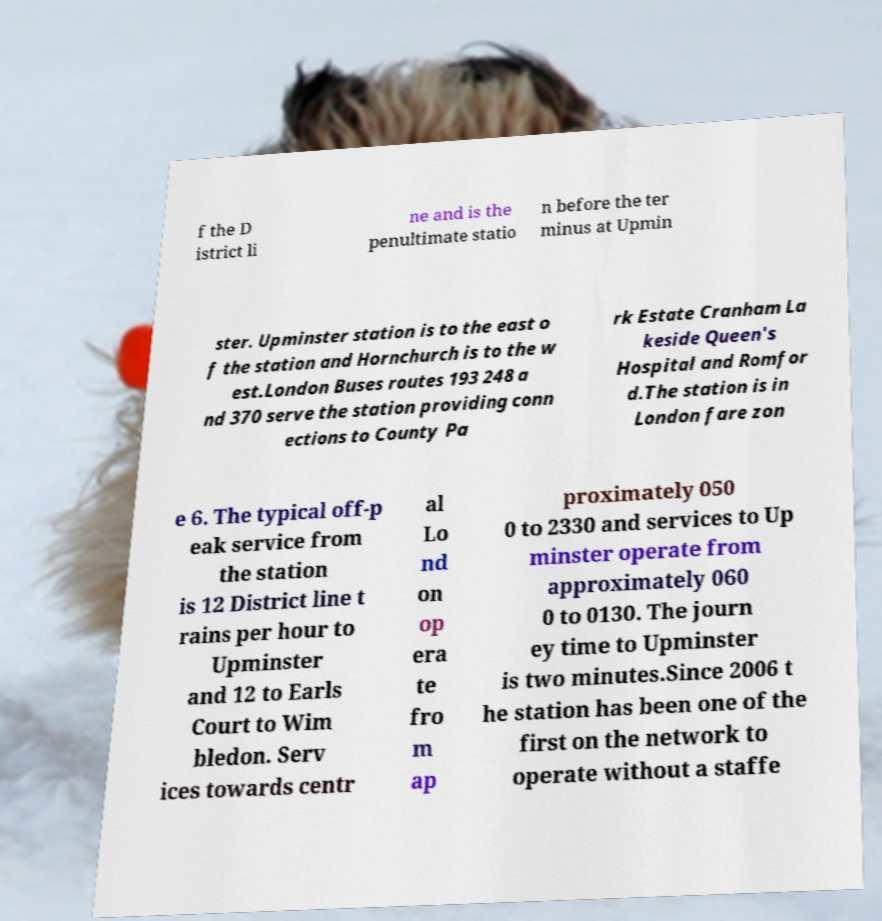What messages or text are displayed in this image? I need them in a readable, typed format. f the D istrict li ne and is the penultimate statio n before the ter minus at Upmin ster. Upminster station is to the east o f the station and Hornchurch is to the w est.London Buses routes 193 248 a nd 370 serve the station providing conn ections to County Pa rk Estate Cranham La keside Queen's Hospital and Romfor d.The station is in London fare zon e 6. The typical off-p eak service from the station is 12 District line t rains per hour to Upminster and 12 to Earls Court to Wim bledon. Serv ices towards centr al Lo nd on op era te fro m ap proximately 050 0 to 2330 and services to Up minster operate from approximately 060 0 to 0130. The journ ey time to Upminster is two minutes.Since 2006 t he station has been one of the first on the network to operate without a staffe 